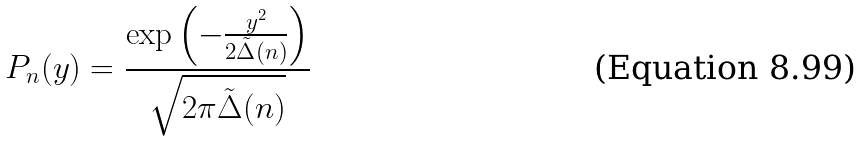<formula> <loc_0><loc_0><loc_500><loc_500>P _ { n } ( y ) = \frac { \exp \left ( - \frac { y ^ { 2 } } { 2 { \tilde { \Delta } } ( n ) } \right ) } { \sqrt { 2 \pi { \tilde { \Delta } } ( n ) } }</formula> 